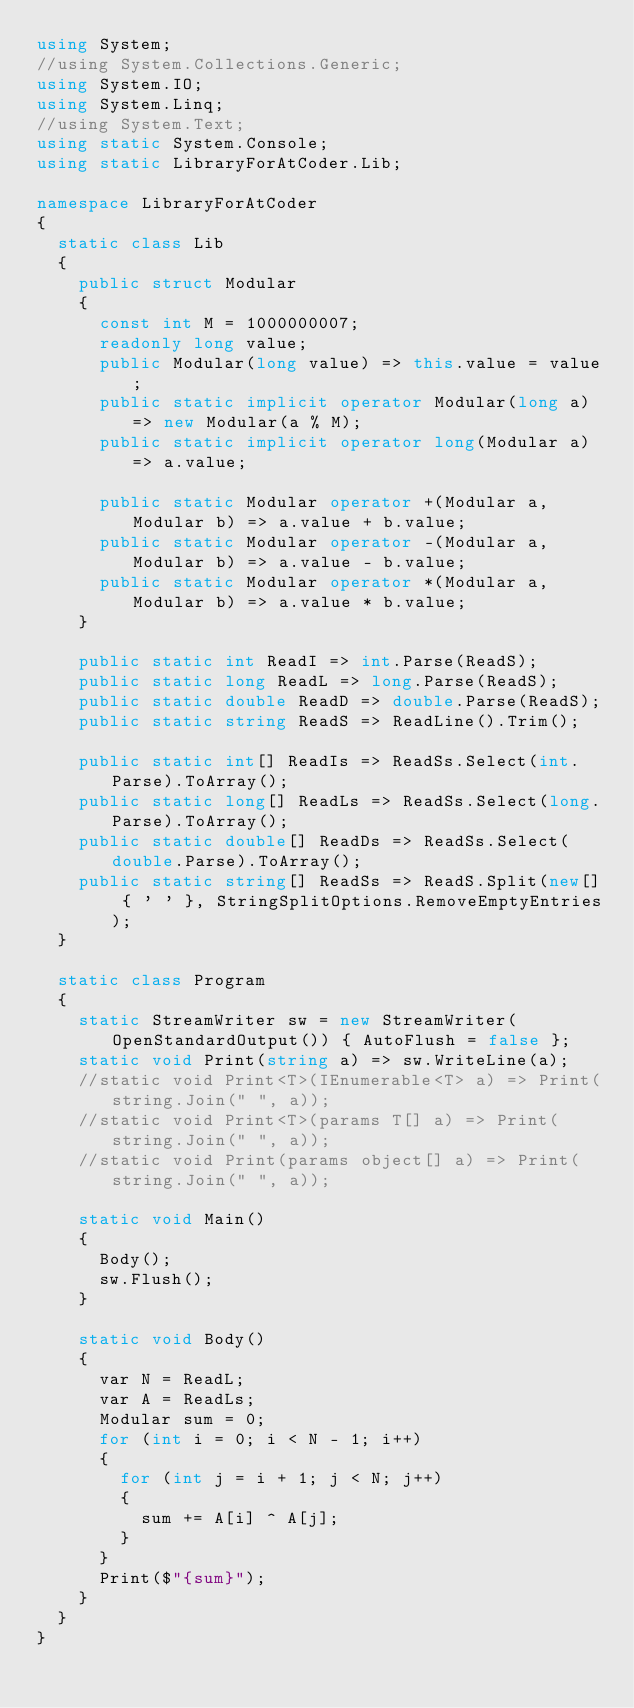Convert code to text. <code><loc_0><loc_0><loc_500><loc_500><_C#_>using System;
//using System.Collections.Generic;
using System.IO;
using System.Linq;
//using System.Text;
using static System.Console;
using static LibraryForAtCoder.Lib;

namespace LibraryForAtCoder
{
  static class Lib
  {
    public struct Modular
    {
      const int M = 1000000007;
      readonly long value;
      public Modular(long value) => this.value = value;
      public static implicit operator Modular(long a) => new Modular(a % M);
      public static implicit operator long(Modular a) => a.value;

      public static Modular operator +(Modular a, Modular b) => a.value + b.value;
      public static Modular operator -(Modular a, Modular b) => a.value - b.value;
      public static Modular operator *(Modular a, Modular b) => a.value * b.value;
    }

    public static int ReadI => int.Parse(ReadS);
    public static long ReadL => long.Parse(ReadS);
    public static double ReadD => double.Parse(ReadS);
    public static string ReadS => ReadLine().Trim();

    public static int[] ReadIs => ReadSs.Select(int.Parse).ToArray();
    public static long[] ReadLs => ReadSs.Select(long.Parse).ToArray();
    public static double[] ReadDs => ReadSs.Select(double.Parse).ToArray();
    public static string[] ReadSs => ReadS.Split(new[] { ' ' }, StringSplitOptions.RemoveEmptyEntries);
  }

  static class Program
  {
    static StreamWriter sw = new StreamWriter(OpenStandardOutput()) { AutoFlush = false };
    static void Print(string a) => sw.WriteLine(a);
    //static void Print<T>(IEnumerable<T> a) => Print(string.Join(" ", a));
    //static void Print<T>(params T[] a) => Print(string.Join(" ", a));
    //static void Print(params object[] a) => Print(string.Join(" ", a));

    static void Main()
    {
      Body();
      sw.Flush();
    }

    static void Body()
    {
      var N = ReadL;
      var A = ReadLs;
      Modular sum = 0;
      for (int i = 0; i < N - 1; i++)
      {
        for (int j = i + 1; j < N; j++)
        {
          sum += A[i] ^ A[j];
        }
      }
      Print($"{sum}");
    }
  }
}
</code> 